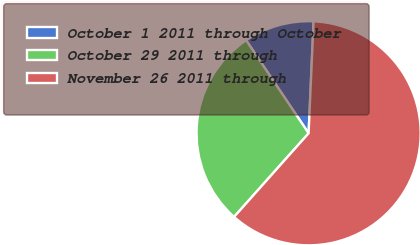<chart> <loc_0><loc_0><loc_500><loc_500><pie_chart><fcel>October 1 2011 through October<fcel>October 29 2011 through<fcel>November 26 2011 through<nl><fcel>10.12%<fcel>29.0%<fcel>60.88%<nl></chart> 